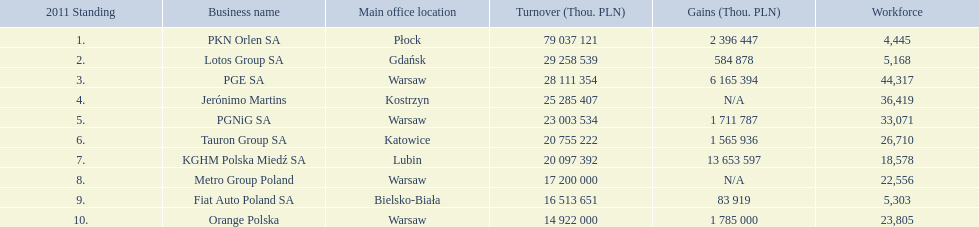What is the number of employees that work for pkn orlen sa in poland? 4,445. What number of employees work for lotos group sa? 5,168. How many people work for pgnig sa? 33,071. 